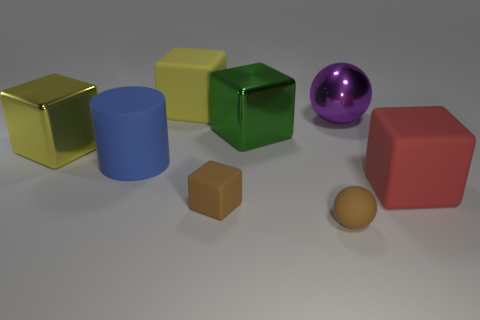What shape is the blue object that is the same material as the red thing?
Ensure brevity in your answer.  Cylinder. Is the size of the green metal thing the same as the purple thing?
Your response must be concise. Yes. How big is the metallic cube that is to the right of the big thing left of the blue matte object?
Offer a very short reply. Large. There is a rubber thing that is the same color as the tiny sphere; what shape is it?
Your response must be concise. Cube. What number of balls are either big yellow things or purple objects?
Provide a short and direct response. 1. Does the brown sphere have the same size as the yellow block that is behind the big purple metal ball?
Make the answer very short. No. Is the number of big cylinders right of the brown rubber sphere greater than the number of brown spheres?
Provide a succinct answer. No. There is a brown object that is the same material as the tiny brown cube; what is its size?
Provide a short and direct response. Small. Are there any other small spheres of the same color as the small sphere?
Make the answer very short. No. What number of objects are large purple shiny objects or things left of the purple sphere?
Your response must be concise. 7. 